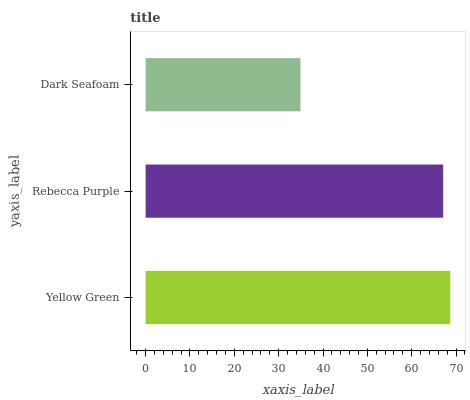Is Dark Seafoam the minimum?
Answer yes or no. Yes. Is Yellow Green the maximum?
Answer yes or no. Yes. Is Rebecca Purple the minimum?
Answer yes or no. No. Is Rebecca Purple the maximum?
Answer yes or no. No. Is Yellow Green greater than Rebecca Purple?
Answer yes or no. Yes. Is Rebecca Purple less than Yellow Green?
Answer yes or no. Yes. Is Rebecca Purple greater than Yellow Green?
Answer yes or no. No. Is Yellow Green less than Rebecca Purple?
Answer yes or no. No. Is Rebecca Purple the high median?
Answer yes or no. Yes. Is Rebecca Purple the low median?
Answer yes or no. Yes. Is Yellow Green the high median?
Answer yes or no. No. Is Yellow Green the low median?
Answer yes or no. No. 